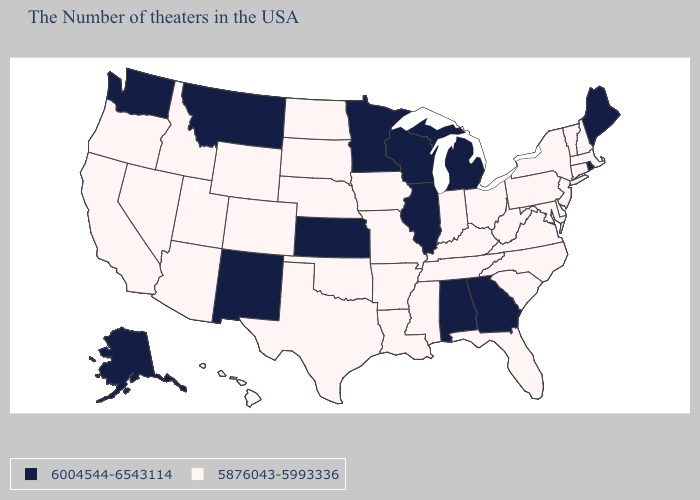Does Ohio have the same value as Wisconsin?
Concise answer only. No. Does West Virginia have the same value as Kansas?
Write a very short answer. No. Which states hav the highest value in the MidWest?
Be succinct. Michigan, Wisconsin, Illinois, Minnesota, Kansas. Among the states that border Utah , which have the highest value?
Write a very short answer. New Mexico. Does the map have missing data?
Give a very brief answer. No. Among the states that border New Mexico , which have the highest value?
Write a very short answer. Oklahoma, Texas, Colorado, Utah, Arizona. Which states have the lowest value in the Northeast?
Answer briefly. Massachusetts, New Hampshire, Vermont, Connecticut, New York, New Jersey, Pennsylvania. Among the states that border Georgia , which have the highest value?
Keep it brief. Alabama. Name the states that have a value in the range 6004544-6543114?
Be succinct. Maine, Rhode Island, Georgia, Michigan, Alabama, Wisconsin, Illinois, Minnesota, Kansas, New Mexico, Montana, Washington, Alaska. Name the states that have a value in the range 6004544-6543114?
Give a very brief answer. Maine, Rhode Island, Georgia, Michigan, Alabama, Wisconsin, Illinois, Minnesota, Kansas, New Mexico, Montana, Washington, Alaska. What is the value of Arizona?
Be succinct. 5876043-5993336. What is the lowest value in the Northeast?
Concise answer only. 5876043-5993336. Name the states that have a value in the range 5876043-5993336?
Keep it brief. Massachusetts, New Hampshire, Vermont, Connecticut, New York, New Jersey, Delaware, Maryland, Pennsylvania, Virginia, North Carolina, South Carolina, West Virginia, Ohio, Florida, Kentucky, Indiana, Tennessee, Mississippi, Louisiana, Missouri, Arkansas, Iowa, Nebraska, Oklahoma, Texas, South Dakota, North Dakota, Wyoming, Colorado, Utah, Arizona, Idaho, Nevada, California, Oregon, Hawaii. What is the value of North Dakota?
Write a very short answer. 5876043-5993336. Does North Carolina have the highest value in the South?
Short answer required. No. 